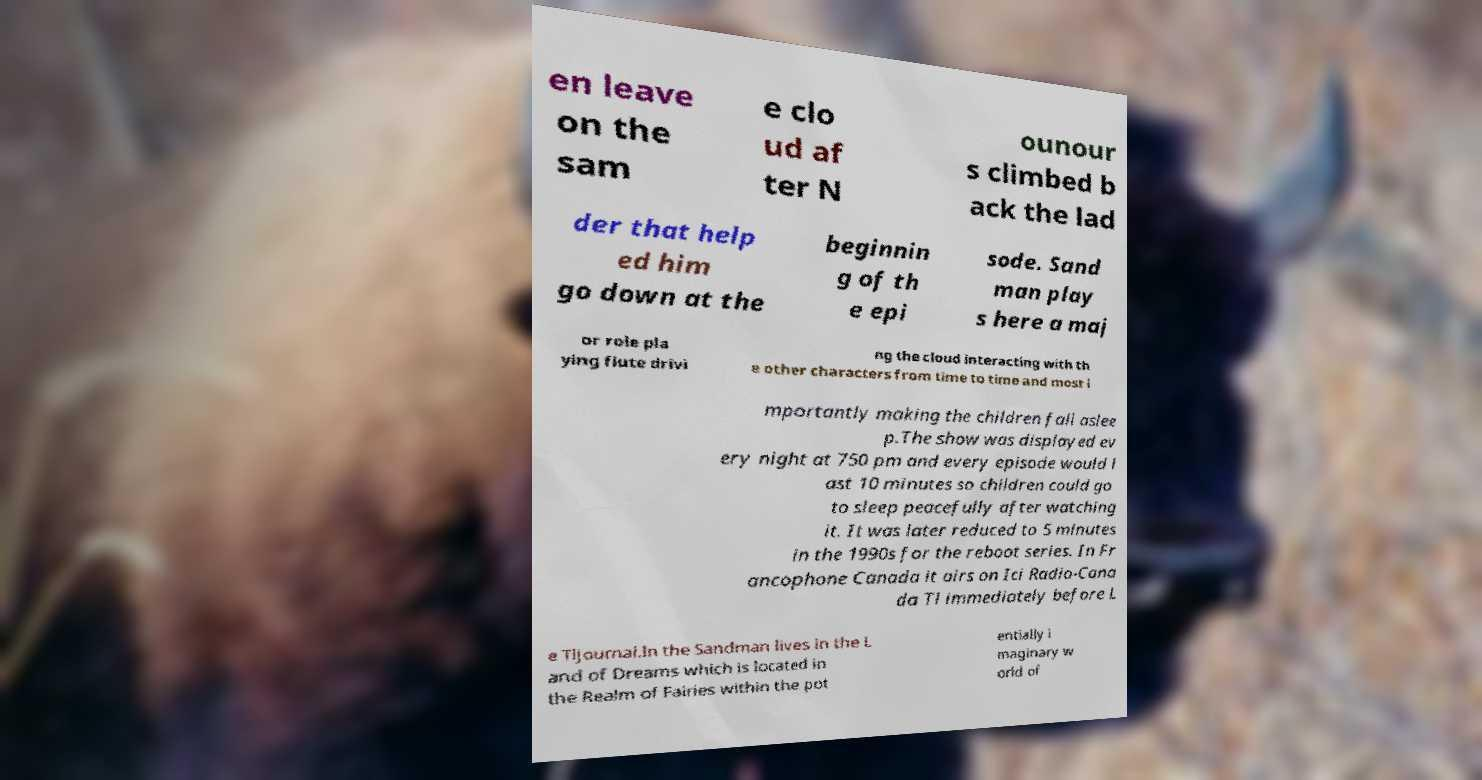I need the written content from this picture converted into text. Can you do that? en leave on the sam e clo ud af ter N ounour s climbed b ack the lad der that help ed him go down at the beginnin g of th e epi sode. Sand man play s here a maj or role pla ying flute drivi ng the cloud interacting with th e other characters from time to time and most i mportantly making the children fall aslee p.The show was displayed ev ery night at 750 pm and every episode would l ast 10 minutes so children could go to sleep peacefully after watching it. It was later reduced to 5 minutes in the 1990s for the reboot series. In Fr ancophone Canada it airs on Ici Radio-Cana da Tl immediately before L e Tljournal.In the Sandman lives in the L and of Dreams which is located in the Realm of Fairies within the pot entially i maginary w orld of 